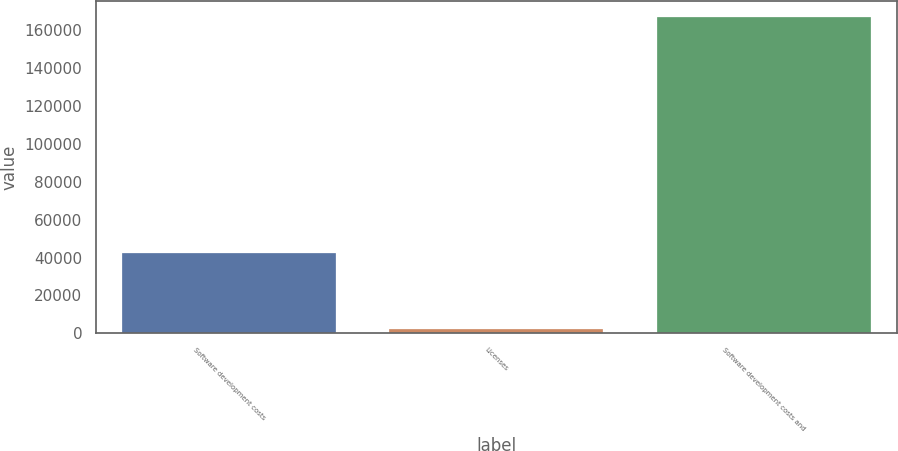Convert chart to OTSL. <chart><loc_0><loc_0><loc_500><loc_500><bar_chart><fcel>Software development costs<fcel>Licenses<fcel>Software development costs and<nl><fcel>42306<fcel>2017<fcel>167341<nl></chart> 